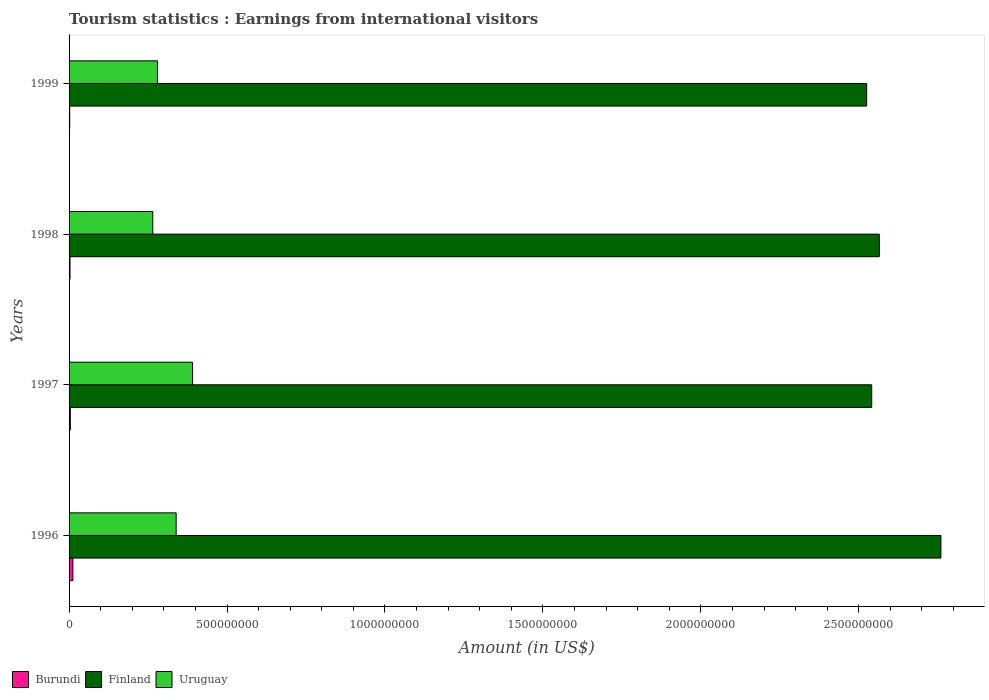How many bars are there on the 1st tick from the top?
Provide a succinct answer. 3. What is the label of the 3rd group of bars from the top?
Your answer should be very brief. 1997. What is the earnings from international visitors in Uruguay in 1998?
Offer a terse response. 2.65e+08. Across all years, what is the maximum earnings from international visitors in Burundi?
Give a very brief answer. 1.20e+07. Across all years, what is the minimum earnings from international visitors in Uruguay?
Make the answer very short. 2.65e+08. What is the total earnings from international visitors in Finland in the graph?
Provide a succinct answer. 1.04e+1. What is the difference between the earnings from international visitors in Burundi in 1997 and that in 1999?
Give a very brief answer. 2.00e+06. What is the difference between the earnings from international visitors in Uruguay in 1997 and the earnings from international visitors in Finland in 1999?
Provide a short and direct response. -2.13e+09. What is the average earnings from international visitors in Uruguay per year?
Provide a succinct answer. 3.19e+08. In the year 1997, what is the difference between the earnings from international visitors in Finland and earnings from international visitors in Uruguay?
Offer a terse response. 2.15e+09. In how many years, is the earnings from international visitors in Burundi greater than 1400000000 US$?
Offer a terse response. 0. What is the ratio of the earnings from international visitors in Uruguay in 1998 to that in 1999?
Ensure brevity in your answer.  0.95. Is the difference between the earnings from international visitors in Finland in 1997 and 1998 greater than the difference between the earnings from international visitors in Uruguay in 1997 and 1998?
Give a very brief answer. No. What is the difference between the highest and the second highest earnings from international visitors in Uruguay?
Your answer should be compact. 5.20e+07. What is the difference between the highest and the lowest earnings from international visitors in Finland?
Offer a very short reply. 2.35e+08. In how many years, is the earnings from international visitors in Finland greater than the average earnings from international visitors in Finland taken over all years?
Make the answer very short. 1. What does the 3rd bar from the top in 1997 represents?
Provide a succinct answer. Burundi. What does the 3rd bar from the bottom in 1997 represents?
Provide a short and direct response. Uruguay. Are all the bars in the graph horizontal?
Your answer should be very brief. Yes. How many years are there in the graph?
Make the answer very short. 4. What is the difference between two consecutive major ticks on the X-axis?
Provide a short and direct response. 5.00e+08. Does the graph contain any zero values?
Offer a terse response. No. Does the graph contain grids?
Your response must be concise. No. Where does the legend appear in the graph?
Your answer should be very brief. Bottom left. What is the title of the graph?
Give a very brief answer. Tourism statistics : Earnings from international visitors. Does "Heavily indebted poor countries" appear as one of the legend labels in the graph?
Offer a very short reply. No. What is the label or title of the Y-axis?
Provide a short and direct response. Years. What is the Amount (in US$) in Burundi in 1996?
Provide a short and direct response. 1.20e+07. What is the Amount (in US$) of Finland in 1996?
Offer a very short reply. 2.76e+09. What is the Amount (in US$) in Uruguay in 1996?
Provide a short and direct response. 3.39e+08. What is the Amount (in US$) in Finland in 1997?
Your answer should be compact. 2.54e+09. What is the Amount (in US$) of Uruguay in 1997?
Provide a short and direct response. 3.91e+08. What is the Amount (in US$) in Burundi in 1998?
Your answer should be very brief. 3.00e+06. What is the Amount (in US$) of Finland in 1998?
Your answer should be compact. 2.56e+09. What is the Amount (in US$) of Uruguay in 1998?
Your answer should be compact. 2.65e+08. What is the Amount (in US$) of Burundi in 1999?
Ensure brevity in your answer.  2.00e+06. What is the Amount (in US$) in Finland in 1999?
Make the answer very short. 2.52e+09. What is the Amount (in US$) in Uruguay in 1999?
Make the answer very short. 2.80e+08. Across all years, what is the maximum Amount (in US$) in Burundi?
Your answer should be very brief. 1.20e+07. Across all years, what is the maximum Amount (in US$) in Finland?
Make the answer very short. 2.76e+09. Across all years, what is the maximum Amount (in US$) in Uruguay?
Provide a succinct answer. 3.91e+08. Across all years, what is the minimum Amount (in US$) of Finland?
Your answer should be compact. 2.52e+09. Across all years, what is the minimum Amount (in US$) of Uruguay?
Offer a terse response. 2.65e+08. What is the total Amount (in US$) of Burundi in the graph?
Make the answer very short. 2.10e+07. What is the total Amount (in US$) in Finland in the graph?
Provide a short and direct response. 1.04e+1. What is the total Amount (in US$) of Uruguay in the graph?
Make the answer very short. 1.28e+09. What is the difference between the Amount (in US$) in Burundi in 1996 and that in 1997?
Your answer should be compact. 8.00e+06. What is the difference between the Amount (in US$) of Finland in 1996 and that in 1997?
Your response must be concise. 2.19e+08. What is the difference between the Amount (in US$) of Uruguay in 1996 and that in 1997?
Ensure brevity in your answer.  -5.20e+07. What is the difference between the Amount (in US$) in Burundi in 1996 and that in 1998?
Make the answer very short. 9.00e+06. What is the difference between the Amount (in US$) in Finland in 1996 and that in 1998?
Offer a terse response. 1.95e+08. What is the difference between the Amount (in US$) of Uruguay in 1996 and that in 1998?
Give a very brief answer. 7.40e+07. What is the difference between the Amount (in US$) in Burundi in 1996 and that in 1999?
Provide a short and direct response. 1.00e+07. What is the difference between the Amount (in US$) of Finland in 1996 and that in 1999?
Give a very brief answer. 2.35e+08. What is the difference between the Amount (in US$) of Uruguay in 1996 and that in 1999?
Offer a very short reply. 5.90e+07. What is the difference between the Amount (in US$) of Finland in 1997 and that in 1998?
Your response must be concise. -2.40e+07. What is the difference between the Amount (in US$) of Uruguay in 1997 and that in 1998?
Offer a very short reply. 1.26e+08. What is the difference between the Amount (in US$) in Finland in 1997 and that in 1999?
Offer a very short reply. 1.60e+07. What is the difference between the Amount (in US$) of Uruguay in 1997 and that in 1999?
Make the answer very short. 1.11e+08. What is the difference between the Amount (in US$) in Burundi in 1998 and that in 1999?
Offer a terse response. 1.00e+06. What is the difference between the Amount (in US$) in Finland in 1998 and that in 1999?
Give a very brief answer. 4.00e+07. What is the difference between the Amount (in US$) in Uruguay in 1998 and that in 1999?
Keep it short and to the point. -1.50e+07. What is the difference between the Amount (in US$) in Burundi in 1996 and the Amount (in US$) in Finland in 1997?
Your response must be concise. -2.53e+09. What is the difference between the Amount (in US$) in Burundi in 1996 and the Amount (in US$) in Uruguay in 1997?
Keep it short and to the point. -3.79e+08. What is the difference between the Amount (in US$) in Finland in 1996 and the Amount (in US$) in Uruguay in 1997?
Give a very brief answer. 2.37e+09. What is the difference between the Amount (in US$) of Burundi in 1996 and the Amount (in US$) of Finland in 1998?
Your answer should be compact. -2.55e+09. What is the difference between the Amount (in US$) of Burundi in 1996 and the Amount (in US$) of Uruguay in 1998?
Offer a very short reply. -2.53e+08. What is the difference between the Amount (in US$) of Finland in 1996 and the Amount (in US$) of Uruguay in 1998?
Offer a terse response. 2.50e+09. What is the difference between the Amount (in US$) in Burundi in 1996 and the Amount (in US$) in Finland in 1999?
Your answer should be compact. -2.51e+09. What is the difference between the Amount (in US$) of Burundi in 1996 and the Amount (in US$) of Uruguay in 1999?
Offer a terse response. -2.68e+08. What is the difference between the Amount (in US$) in Finland in 1996 and the Amount (in US$) in Uruguay in 1999?
Offer a very short reply. 2.48e+09. What is the difference between the Amount (in US$) of Burundi in 1997 and the Amount (in US$) of Finland in 1998?
Make the answer very short. -2.56e+09. What is the difference between the Amount (in US$) of Burundi in 1997 and the Amount (in US$) of Uruguay in 1998?
Provide a succinct answer. -2.61e+08. What is the difference between the Amount (in US$) in Finland in 1997 and the Amount (in US$) in Uruguay in 1998?
Offer a very short reply. 2.28e+09. What is the difference between the Amount (in US$) in Burundi in 1997 and the Amount (in US$) in Finland in 1999?
Offer a terse response. -2.52e+09. What is the difference between the Amount (in US$) of Burundi in 1997 and the Amount (in US$) of Uruguay in 1999?
Your answer should be very brief. -2.76e+08. What is the difference between the Amount (in US$) of Finland in 1997 and the Amount (in US$) of Uruguay in 1999?
Your answer should be compact. 2.26e+09. What is the difference between the Amount (in US$) of Burundi in 1998 and the Amount (in US$) of Finland in 1999?
Ensure brevity in your answer.  -2.52e+09. What is the difference between the Amount (in US$) of Burundi in 1998 and the Amount (in US$) of Uruguay in 1999?
Your answer should be compact. -2.77e+08. What is the difference between the Amount (in US$) of Finland in 1998 and the Amount (in US$) of Uruguay in 1999?
Your answer should be very brief. 2.28e+09. What is the average Amount (in US$) in Burundi per year?
Offer a terse response. 5.25e+06. What is the average Amount (in US$) in Finland per year?
Your answer should be compact. 2.60e+09. What is the average Amount (in US$) of Uruguay per year?
Make the answer very short. 3.19e+08. In the year 1996, what is the difference between the Amount (in US$) in Burundi and Amount (in US$) in Finland?
Provide a succinct answer. -2.75e+09. In the year 1996, what is the difference between the Amount (in US$) of Burundi and Amount (in US$) of Uruguay?
Keep it short and to the point. -3.27e+08. In the year 1996, what is the difference between the Amount (in US$) in Finland and Amount (in US$) in Uruguay?
Ensure brevity in your answer.  2.42e+09. In the year 1997, what is the difference between the Amount (in US$) in Burundi and Amount (in US$) in Finland?
Your answer should be very brief. -2.54e+09. In the year 1997, what is the difference between the Amount (in US$) in Burundi and Amount (in US$) in Uruguay?
Provide a succinct answer. -3.87e+08. In the year 1997, what is the difference between the Amount (in US$) of Finland and Amount (in US$) of Uruguay?
Provide a succinct answer. 2.15e+09. In the year 1998, what is the difference between the Amount (in US$) of Burundi and Amount (in US$) of Finland?
Your answer should be very brief. -2.56e+09. In the year 1998, what is the difference between the Amount (in US$) of Burundi and Amount (in US$) of Uruguay?
Keep it short and to the point. -2.62e+08. In the year 1998, what is the difference between the Amount (in US$) in Finland and Amount (in US$) in Uruguay?
Make the answer very short. 2.30e+09. In the year 1999, what is the difference between the Amount (in US$) of Burundi and Amount (in US$) of Finland?
Ensure brevity in your answer.  -2.52e+09. In the year 1999, what is the difference between the Amount (in US$) of Burundi and Amount (in US$) of Uruguay?
Your response must be concise. -2.78e+08. In the year 1999, what is the difference between the Amount (in US$) in Finland and Amount (in US$) in Uruguay?
Your answer should be very brief. 2.24e+09. What is the ratio of the Amount (in US$) in Finland in 1996 to that in 1997?
Ensure brevity in your answer.  1.09. What is the ratio of the Amount (in US$) in Uruguay in 1996 to that in 1997?
Provide a short and direct response. 0.87. What is the ratio of the Amount (in US$) of Finland in 1996 to that in 1998?
Offer a terse response. 1.08. What is the ratio of the Amount (in US$) of Uruguay in 1996 to that in 1998?
Provide a short and direct response. 1.28. What is the ratio of the Amount (in US$) of Burundi in 1996 to that in 1999?
Offer a terse response. 6. What is the ratio of the Amount (in US$) in Finland in 1996 to that in 1999?
Ensure brevity in your answer.  1.09. What is the ratio of the Amount (in US$) of Uruguay in 1996 to that in 1999?
Make the answer very short. 1.21. What is the ratio of the Amount (in US$) in Finland in 1997 to that in 1998?
Keep it short and to the point. 0.99. What is the ratio of the Amount (in US$) of Uruguay in 1997 to that in 1998?
Your answer should be compact. 1.48. What is the ratio of the Amount (in US$) of Uruguay in 1997 to that in 1999?
Your answer should be very brief. 1.4. What is the ratio of the Amount (in US$) of Finland in 1998 to that in 1999?
Your answer should be very brief. 1.02. What is the ratio of the Amount (in US$) in Uruguay in 1998 to that in 1999?
Ensure brevity in your answer.  0.95. What is the difference between the highest and the second highest Amount (in US$) of Burundi?
Provide a short and direct response. 8.00e+06. What is the difference between the highest and the second highest Amount (in US$) of Finland?
Your answer should be very brief. 1.95e+08. What is the difference between the highest and the second highest Amount (in US$) in Uruguay?
Offer a very short reply. 5.20e+07. What is the difference between the highest and the lowest Amount (in US$) in Finland?
Provide a succinct answer. 2.35e+08. What is the difference between the highest and the lowest Amount (in US$) in Uruguay?
Your answer should be compact. 1.26e+08. 